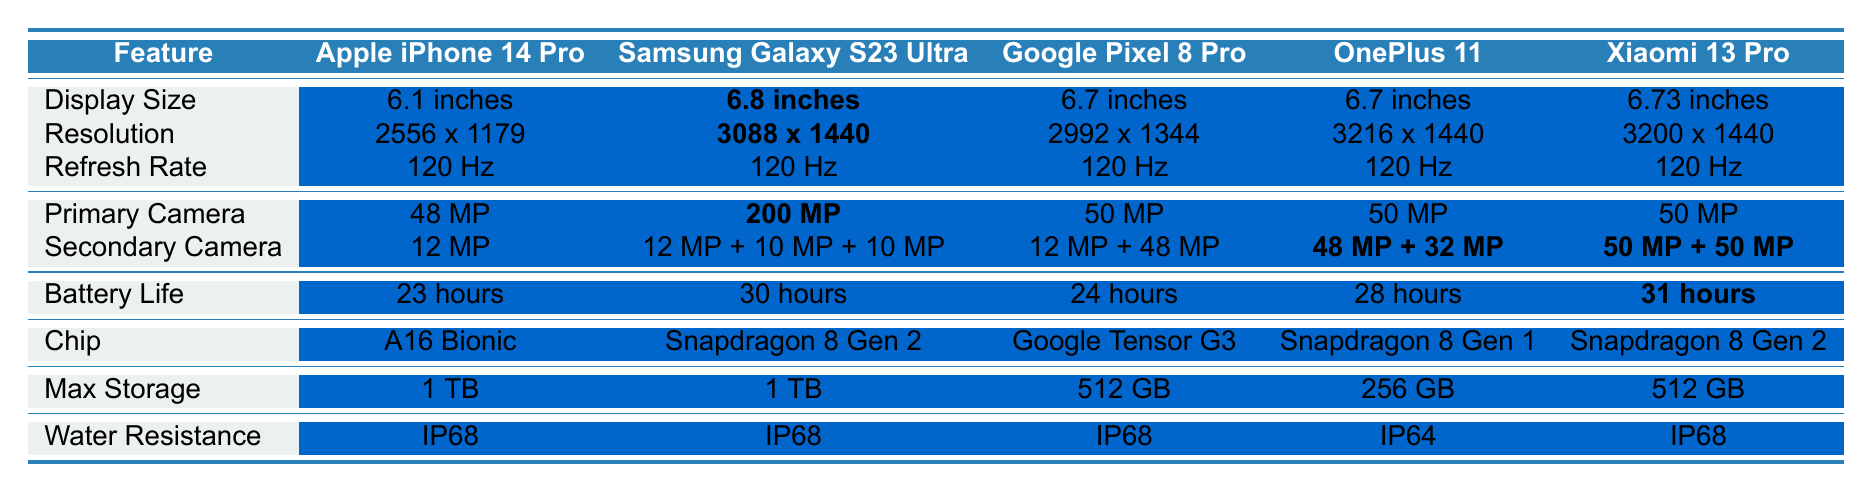What is the display size of the Samsung Galaxy S23 Ultra? The table lists the display size of each product, and for the Samsung Galaxy S23 Ultra, the value is bolded, showing it as 6.8 inches.
Answer: 6.8 inches Which product has the highest primary camera resolution? By comparing the primary camera resolutions in the table, the Samsung Galaxy S23 Ultra has the highest at 200 MP.
Answer: 200 MP What is the battery life of the OnePlus 11? The table indicates the battery life for each product, and for the OnePlus 11, it states that the battery life is 28 hours.
Answer: 28 hours True or False: All products have an IP68 water resistance rating. By checking the water resistance ratings in the table, I see that the OnePlus 11 has an IP64 rating, which means not all products have an IP68 rating.
Answer: False What is the difference in battery life between the Apple iPhone 14 Pro and the Xiaomi 13 Pro? The battery life for the Apple iPhone 14 Pro is 23 hours, and for the Xiaomi 13 Pro, it is 31 hours. The difference is 31 - 23 = 8 hours.
Answer: 8 hours How many products have a refresh rate of 120 Hz? The table shows five products, and all of them have a refresh rate of 120 Hz. Thus, the total is 5.
Answer: 5 Which product offers the maximum storage option of 1 TB? By reviewing the maximum storage options provided in the table, both the Apple iPhone 14 Pro and the Samsung Galaxy S23 Ultra offer 1 TB of storage.
Answer: Apple iPhone 14 Pro, Samsung Galaxy S23 Ultra What is the average display resolution among all products listed? To find the average, we sum the resolutions: (2556x1179 + 3088x1440 + 2992x1344 + 3216x1440 + 3200x1440). Then, we convert each resolution to a pixel count (1,746,804 + 4,435,520 + 4,006,368 + 4,622,240 + 4,608,000 = 19,418,932) and divide by 5 products giving an average resolution of approximately 3,883,786.4 pixels. However, to maintain clarity: Average resolution in presented format cannot be simplified meaningfully.
Answer: Approx. 3,883,786.4 pixels Which product has both the largest display and the highest primary camera resolution? The largest display is the Samsung Galaxy S23 Ultra at 6.8 inches and it has the highest primary camera resolution at 200 MP. Therefore, this product meets both criteria.
Answer: Samsung Galaxy S23 Ultra 